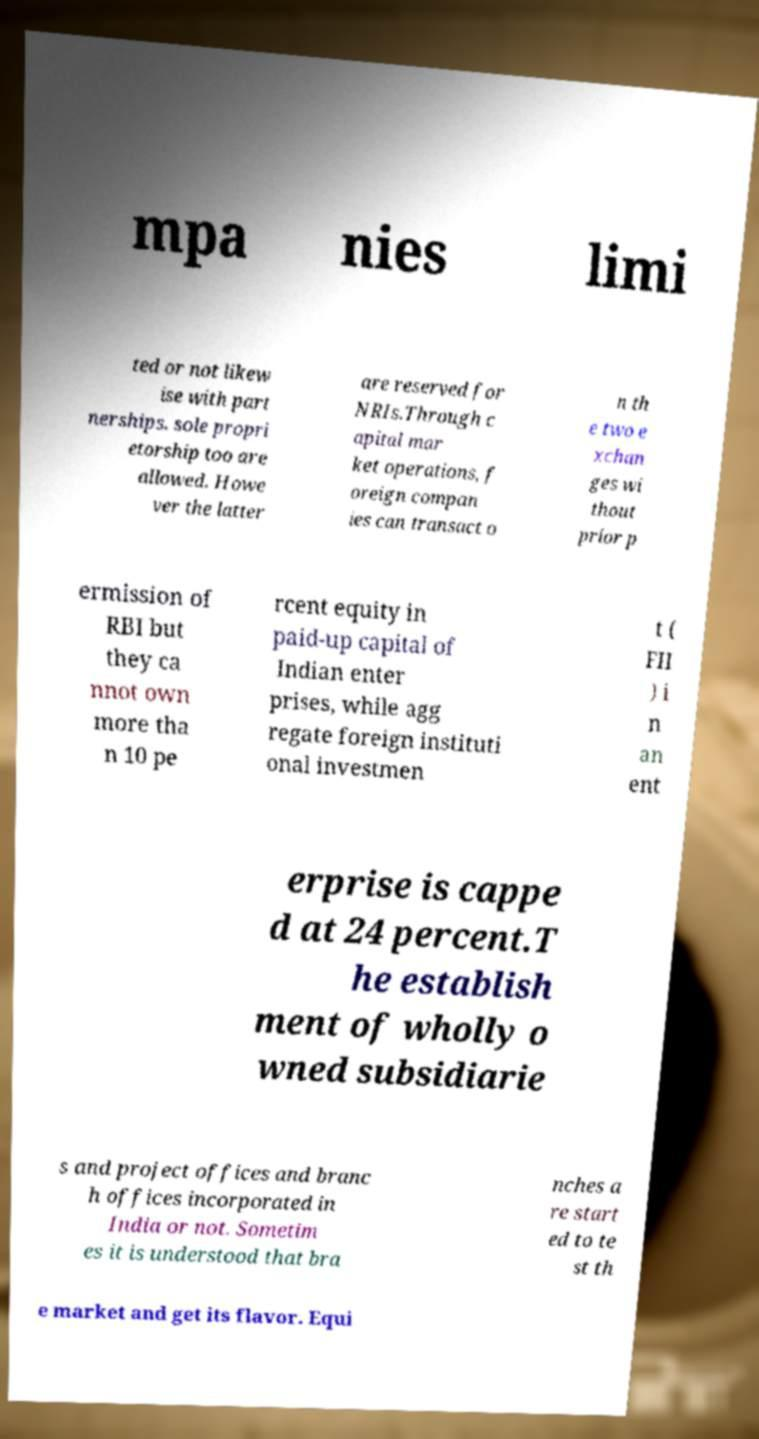Could you assist in decoding the text presented in this image and type it out clearly? mpa nies limi ted or not likew ise with part nerships. sole propri etorship too are allowed. Howe ver the latter are reserved for NRIs.Through c apital mar ket operations, f oreign compan ies can transact o n th e two e xchan ges wi thout prior p ermission of RBI but they ca nnot own more tha n 10 pe rcent equity in paid-up capital of Indian enter prises, while agg regate foreign instituti onal investmen t ( FII ) i n an ent erprise is cappe d at 24 percent.T he establish ment of wholly o wned subsidiarie s and project offices and branc h offices incorporated in India or not. Sometim es it is understood that bra nches a re start ed to te st th e market and get its flavor. Equi 